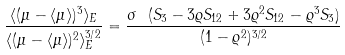Convert formula to latex. <formula><loc_0><loc_0><loc_500><loc_500>\frac { \langle ( \mu - \langle \mu \rangle ) ^ { 3 } \rangle _ { E } } { \langle ( \mu - \langle \mu \rangle ) ^ { 2 } \rangle _ { E } ^ { 3 / 2 } } = \frac { \sigma \ ( S _ { 3 } - 3 \varrho S _ { 1 2 } + 3 \varrho ^ { 2 } S _ { 1 2 } - \varrho ^ { 3 } S _ { 3 } ) } { ( 1 - \varrho ^ { 2 } ) ^ { 3 / 2 } }</formula> 